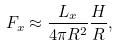<formula> <loc_0><loc_0><loc_500><loc_500>F _ { x } \approx \frac { L _ { x } } { 4 \pi R ^ { 2 } } \frac { H } { R } ,</formula> 